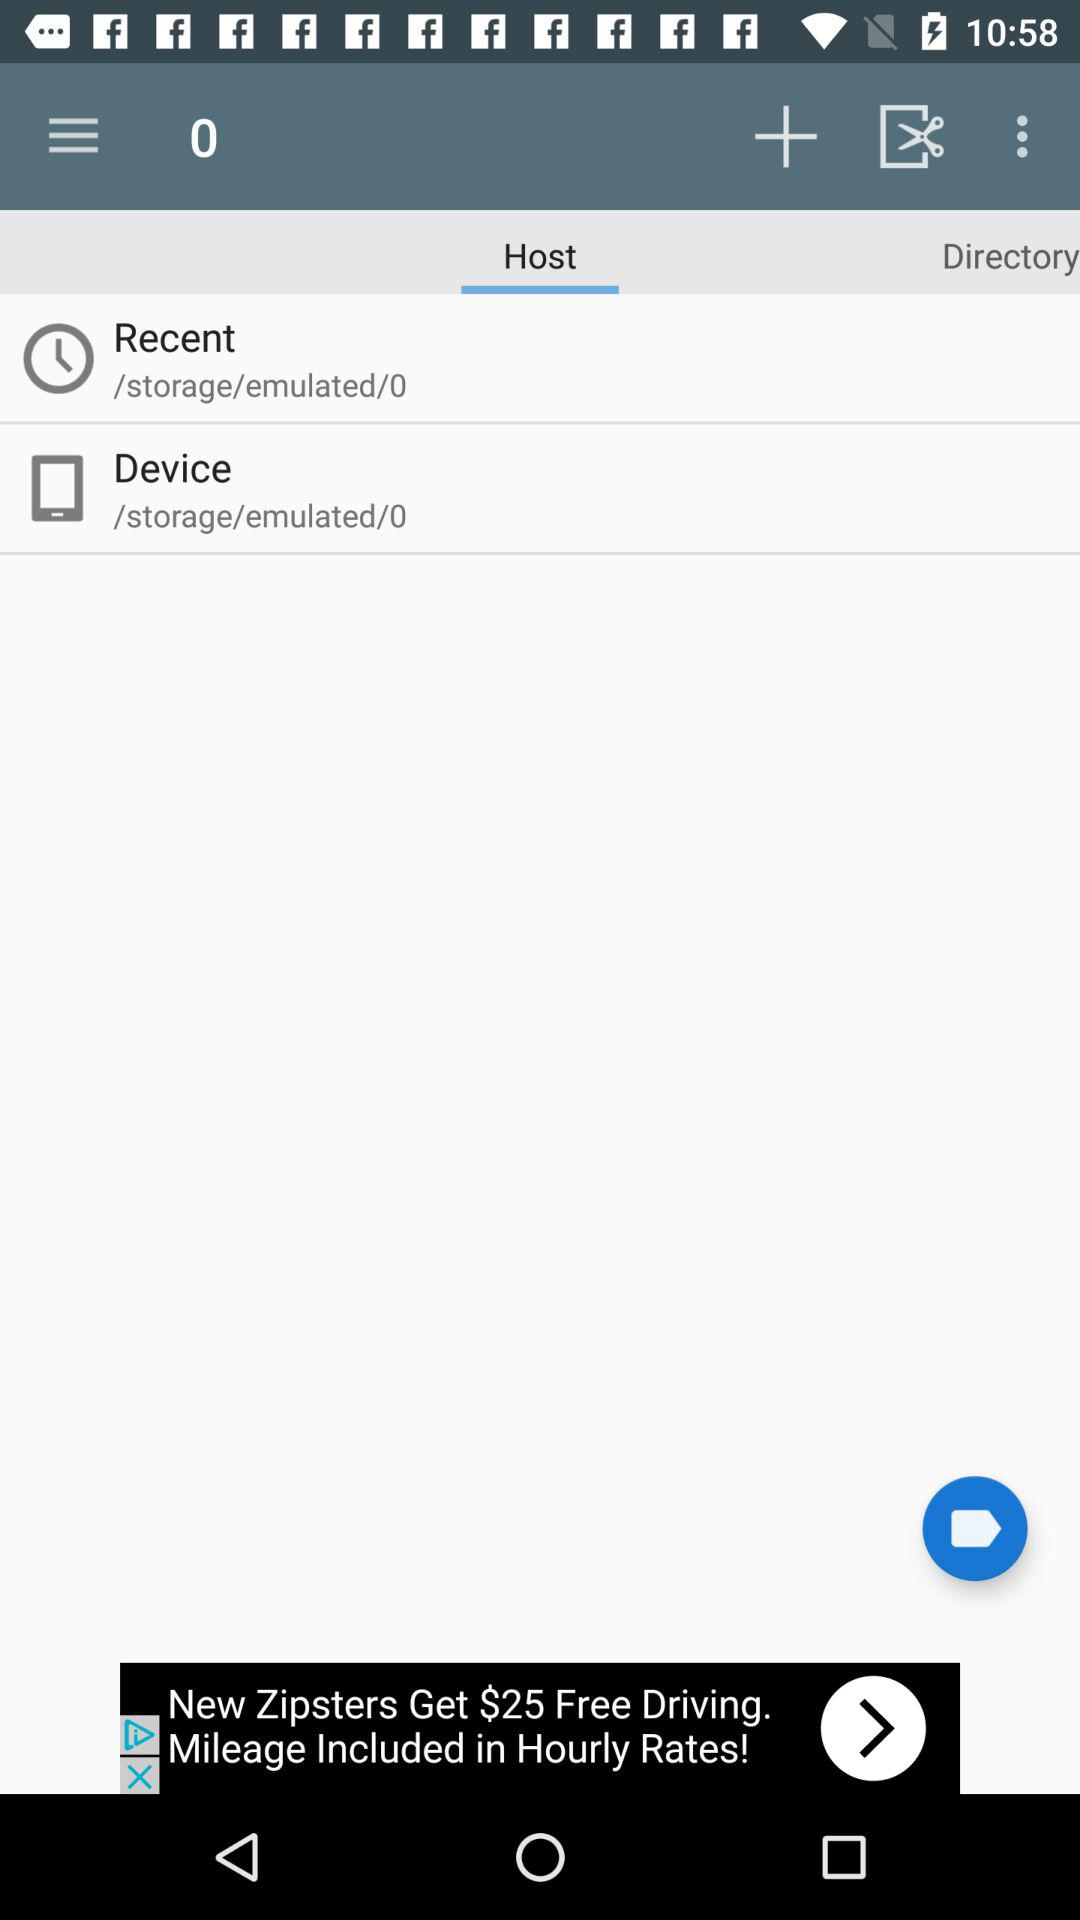What is the selected tab? The selected tab is "Host". 